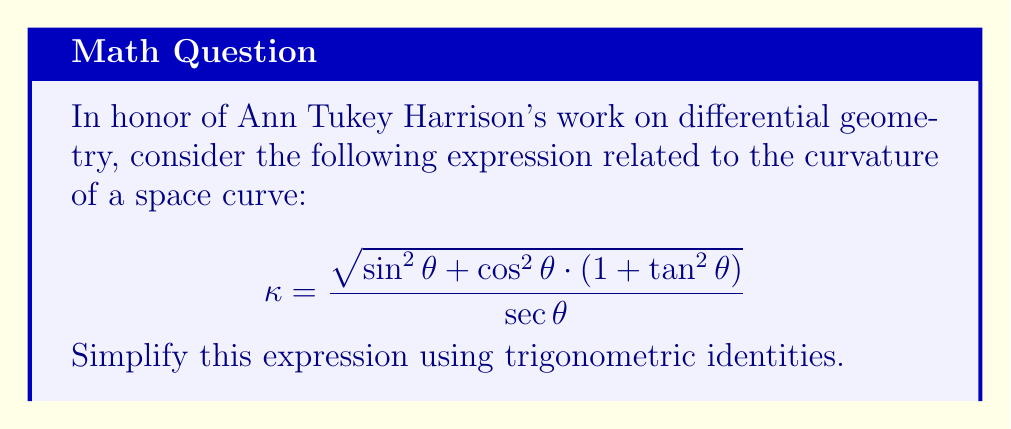Solve this math problem. Let's approach this step-by-step:

1) First, let's focus on the numerator. Inside the square root, we have $\sin^2\theta + \cos^2\theta \cdot (1 + \tan^2\theta)$.

2) We know that $\sin^2\theta + \cos^2\theta = 1$ (Pythagorean identity). Let's keep this in mind.

3) Now, let's look at $\cos^2\theta \cdot (1 + \tan^2\theta)$:
   
   $\tan\theta = \frac{\sin\theta}{\cos\theta}$, so $\tan^2\theta = \frac{\sin^2\theta}{\cos^2\theta}$
   
   Therefore, $\cos^2\theta \cdot (1 + \tan^2\theta) = \cos^2\theta + \sin^2\theta$

4) Now our expression under the square root becomes:
   
   $\sin^2\theta + (\cos^2\theta + \sin^2\theta) = 2(\sin^2\theta + \cos^2\theta) = 2 \cdot 1 = 2$

5) So our expression simplifies to:

   $$\kappa = \frac{\sqrt{2}}{\sec\theta}$$

6) Recall that $\sec\theta = \frac{1}{\cos\theta}$. Therefore:

   $$\kappa = \sqrt{2} \cdot \cos\theta$$

This is our simplified expression.
Answer: $\sqrt{2} \cos\theta$ 